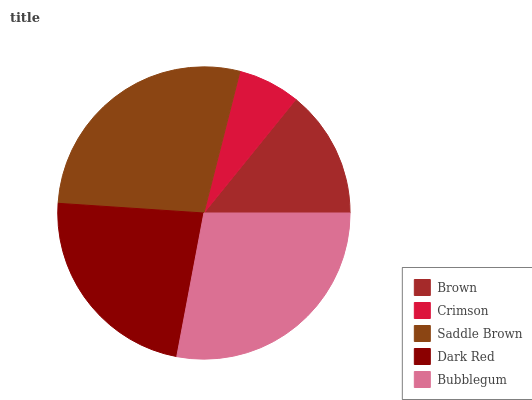Is Crimson the minimum?
Answer yes or no. Yes. Is Bubblegum the maximum?
Answer yes or no. Yes. Is Saddle Brown the minimum?
Answer yes or no. No. Is Saddle Brown the maximum?
Answer yes or no. No. Is Saddle Brown greater than Crimson?
Answer yes or no. Yes. Is Crimson less than Saddle Brown?
Answer yes or no. Yes. Is Crimson greater than Saddle Brown?
Answer yes or no. No. Is Saddle Brown less than Crimson?
Answer yes or no. No. Is Dark Red the high median?
Answer yes or no. Yes. Is Dark Red the low median?
Answer yes or no. Yes. Is Crimson the high median?
Answer yes or no. No. Is Crimson the low median?
Answer yes or no. No. 